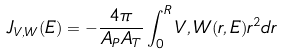Convert formula to latex. <formula><loc_0><loc_0><loc_500><loc_500>J _ { V , W } ( E ) = - \frac { 4 \pi } { A _ { P } A _ { T } } \int _ { 0 } ^ { R } V , W ( r , E ) r ^ { 2 } d r</formula> 